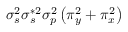Convert formula to latex. <formula><loc_0><loc_0><loc_500><loc_500>\sigma _ { s } ^ { 2 } \sigma _ { s } ^ { * 2 } \sigma _ { p } ^ { 2 } \left ( \pi _ { y } ^ { 2 } + \pi _ { x } ^ { 2 } \right )</formula> 